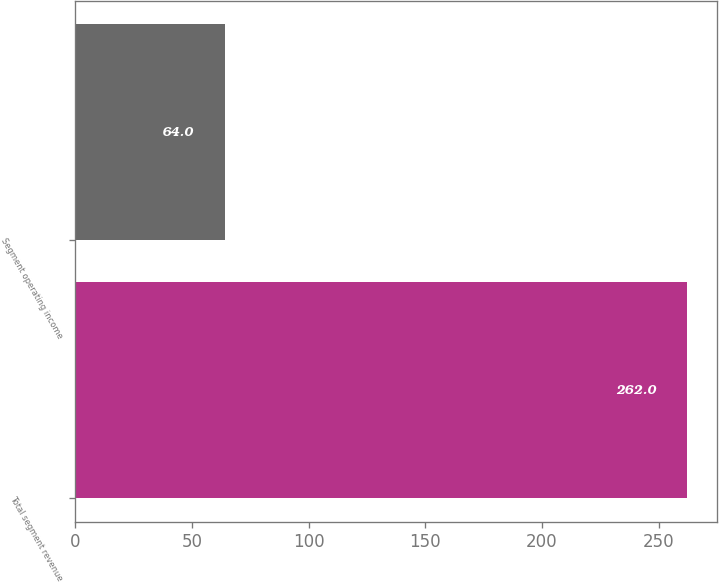Convert chart to OTSL. <chart><loc_0><loc_0><loc_500><loc_500><bar_chart><fcel>Total segment revenue<fcel>Segment operating income<nl><fcel>262<fcel>64<nl></chart> 